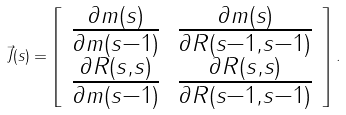<formula> <loc_0><loc_0><loc_500><loc_500>\vec { J } ( s ) = \left [ \begin{array} { c c } \frac { \partial m ( s ) } { \partial m ( s - 1 ) } & \frac { \partial m ( s ) } { \partial R ( s - 1 , s - 1 ) } \\ \frac { \partial R ( s , s ) } { \partial m ( s - 1 ) } & \frac { \partial R ( s , s ) } { \partial R ( s - 1 , s - 1 ) } \end{array} \right ] .</formula> 